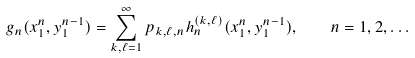<formula> <loc_0><loc_0><loc_500><loc_500>g _ { n } ( x _ { 1 } ^ { n } , y _ { 1 } ^ { n - 1 } ) = \sum _ { k , \ell = 1 } ^ { \infty } p _ { k , \ell , n } h _ { n } ^ { ( k , \ell ) } ( x _ { 1 } ^ { n } , y _ { 1 } ^ { n - 1 } ) , \quad n = 1 , 2 , \dots</formula> 